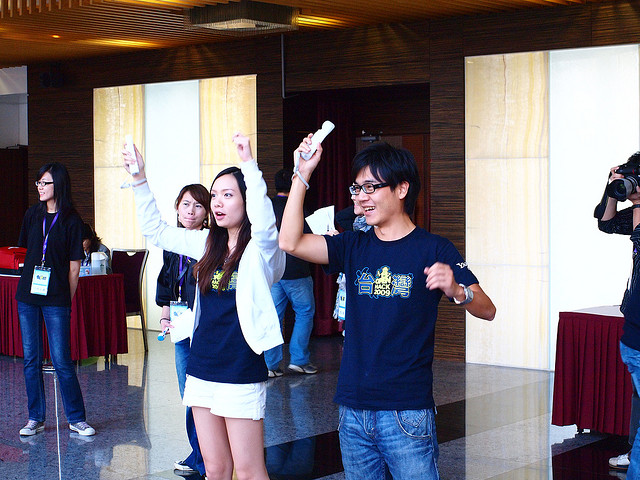Please identify all text content in this image. ot HACK 